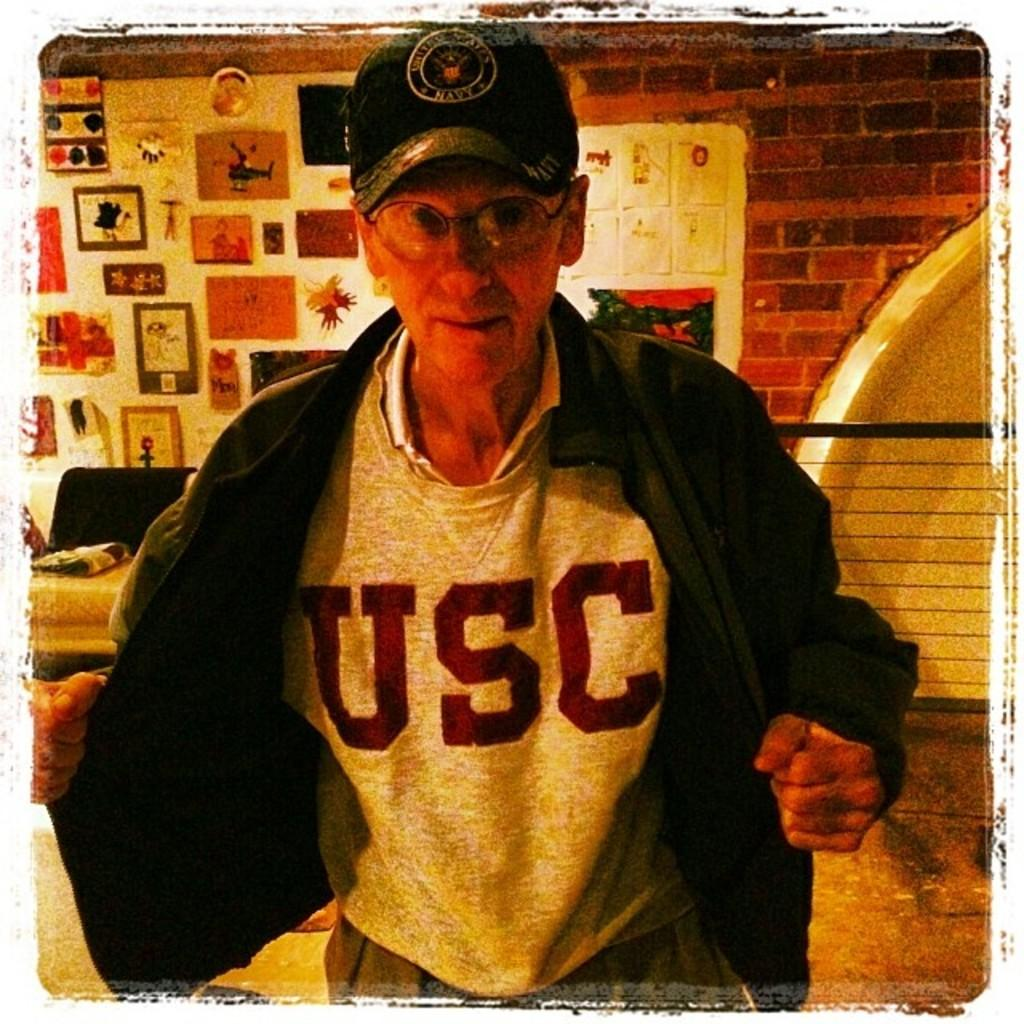<image>
Summarize the visual content of the image. Man wearing a sweater that says USC on it. 